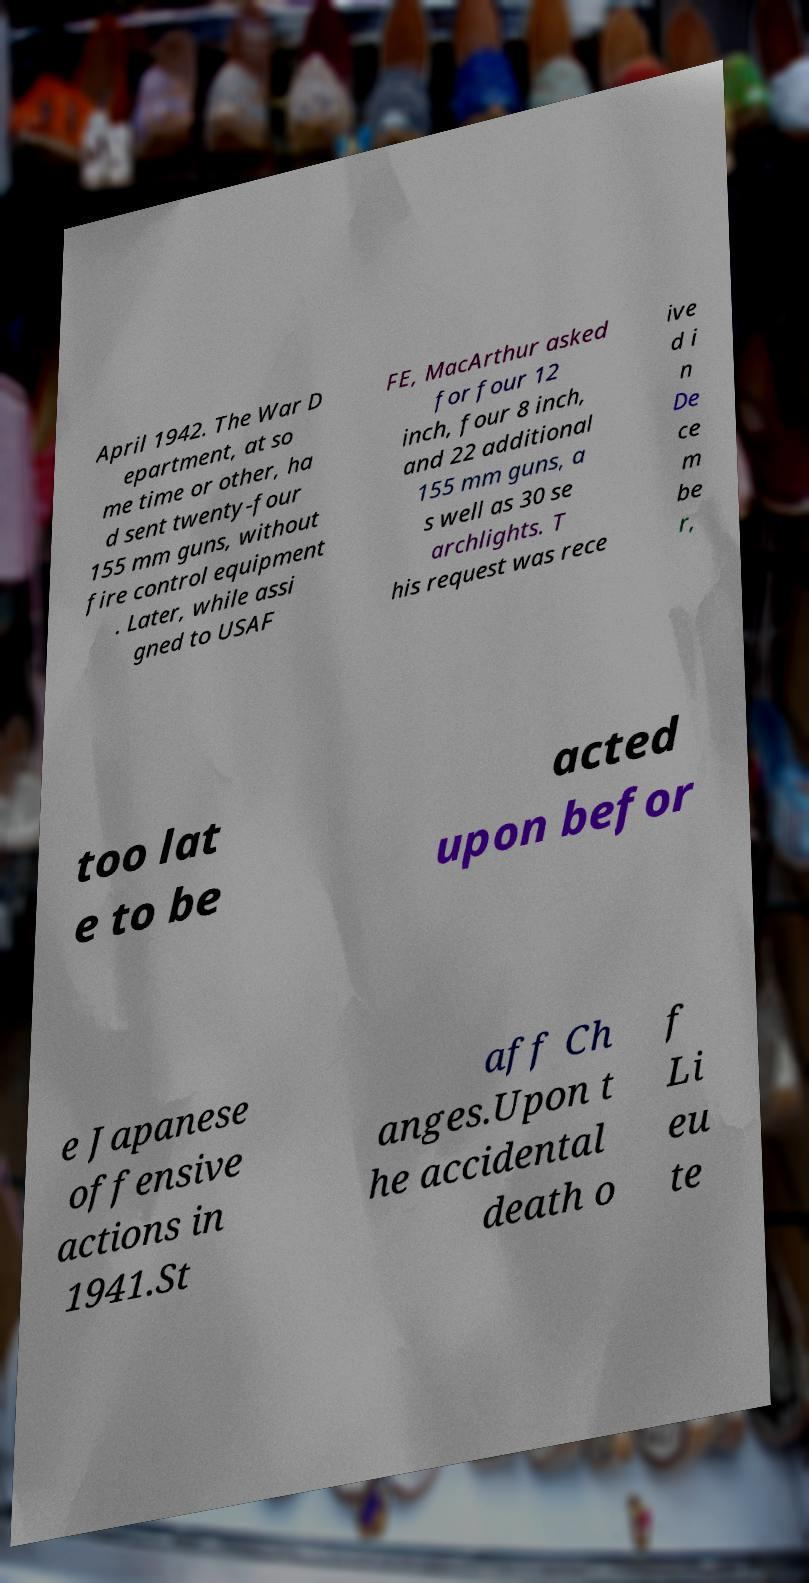Please read and relay the text visible in this image. What does it say? April 1942. The War D epartment, at so me time or other, ha d sent twenty-four 155 mm guns, without fire control equipment . Later, while assi gned to USAF FE, MacArthur asked for four 12 inch, four 8 inch, and 22 additional 155 mm guns, a s well as 30 se archlights. T his request was rece ive d i n De ce m be r, too lat e to be acted upon befor e Japanese offensive actions in 1941.St aff Ch anges.Upon t he accidental death o f Li eu te 